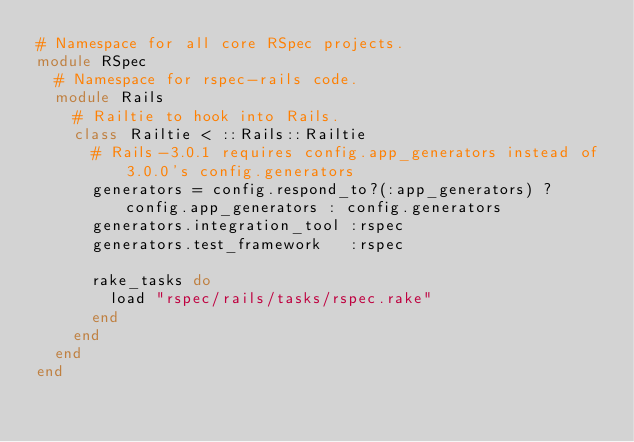Convert code to text. <code><loc_0><loc_0><loc_500><loc_500><_Ruby_># Namespace for all core RSpec projects.
module RSpec
  # Namespace for rspec-rails code.
  module Rails
    # Railtie to hook into Rails.
    class Railtie < ::Rails::Railtie
      # Rails-3.0.1 requires config.app_generators instead of 3.0.0's config.generators
      generators = config.respond_to?(:app_generators) ? config.app_generators : config.generators
      generators.integration_tool :rspec
      generators.test_framework   :rspec

      rake_tasks do
        load "rspec/rails/tasks/rspec.rake"
      end
    end
  end
end
</code> 